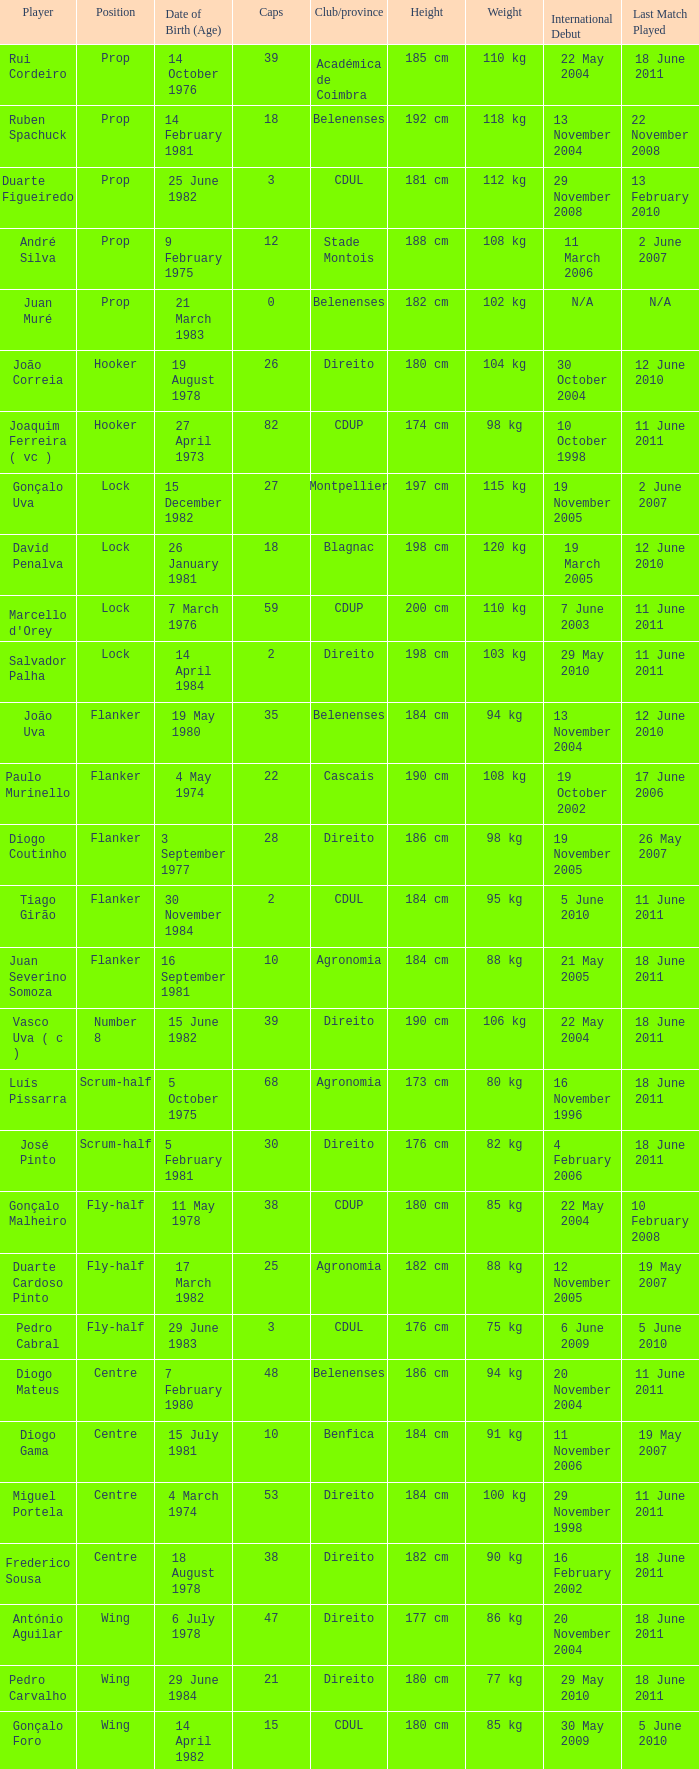Which Club/province has a Player of david penalva? Blagnac. 